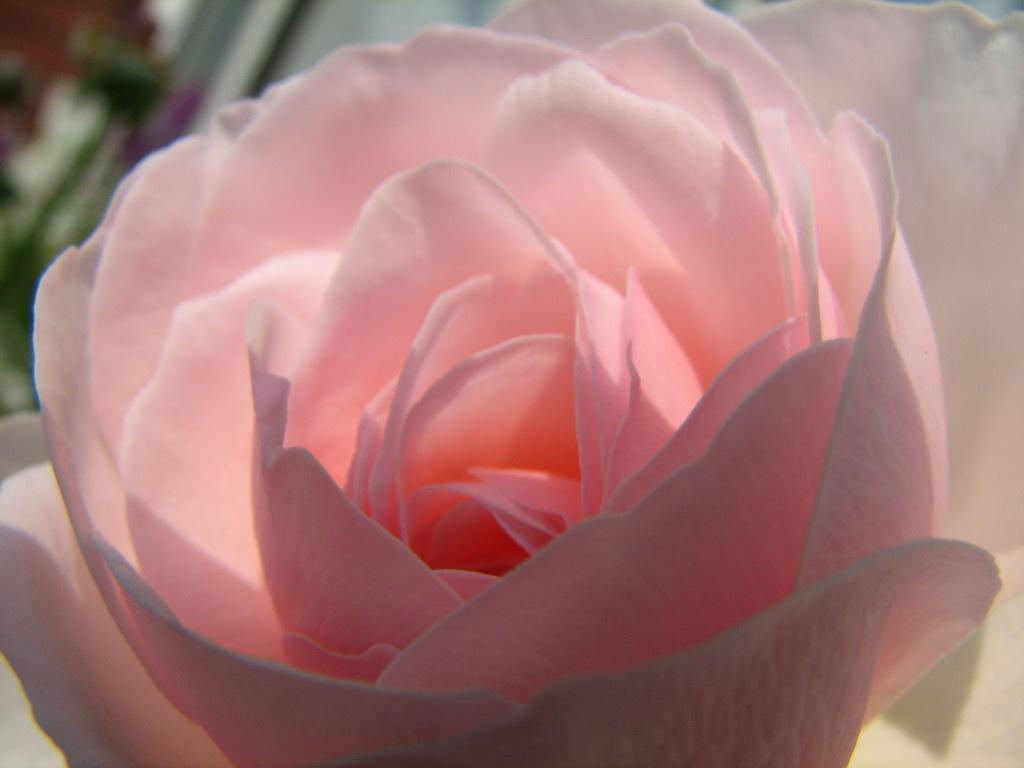Please provide a concise description of this image. In this image the background is a little blurred. In the middle of the image there is a beautiful flower it is light pink in color. 